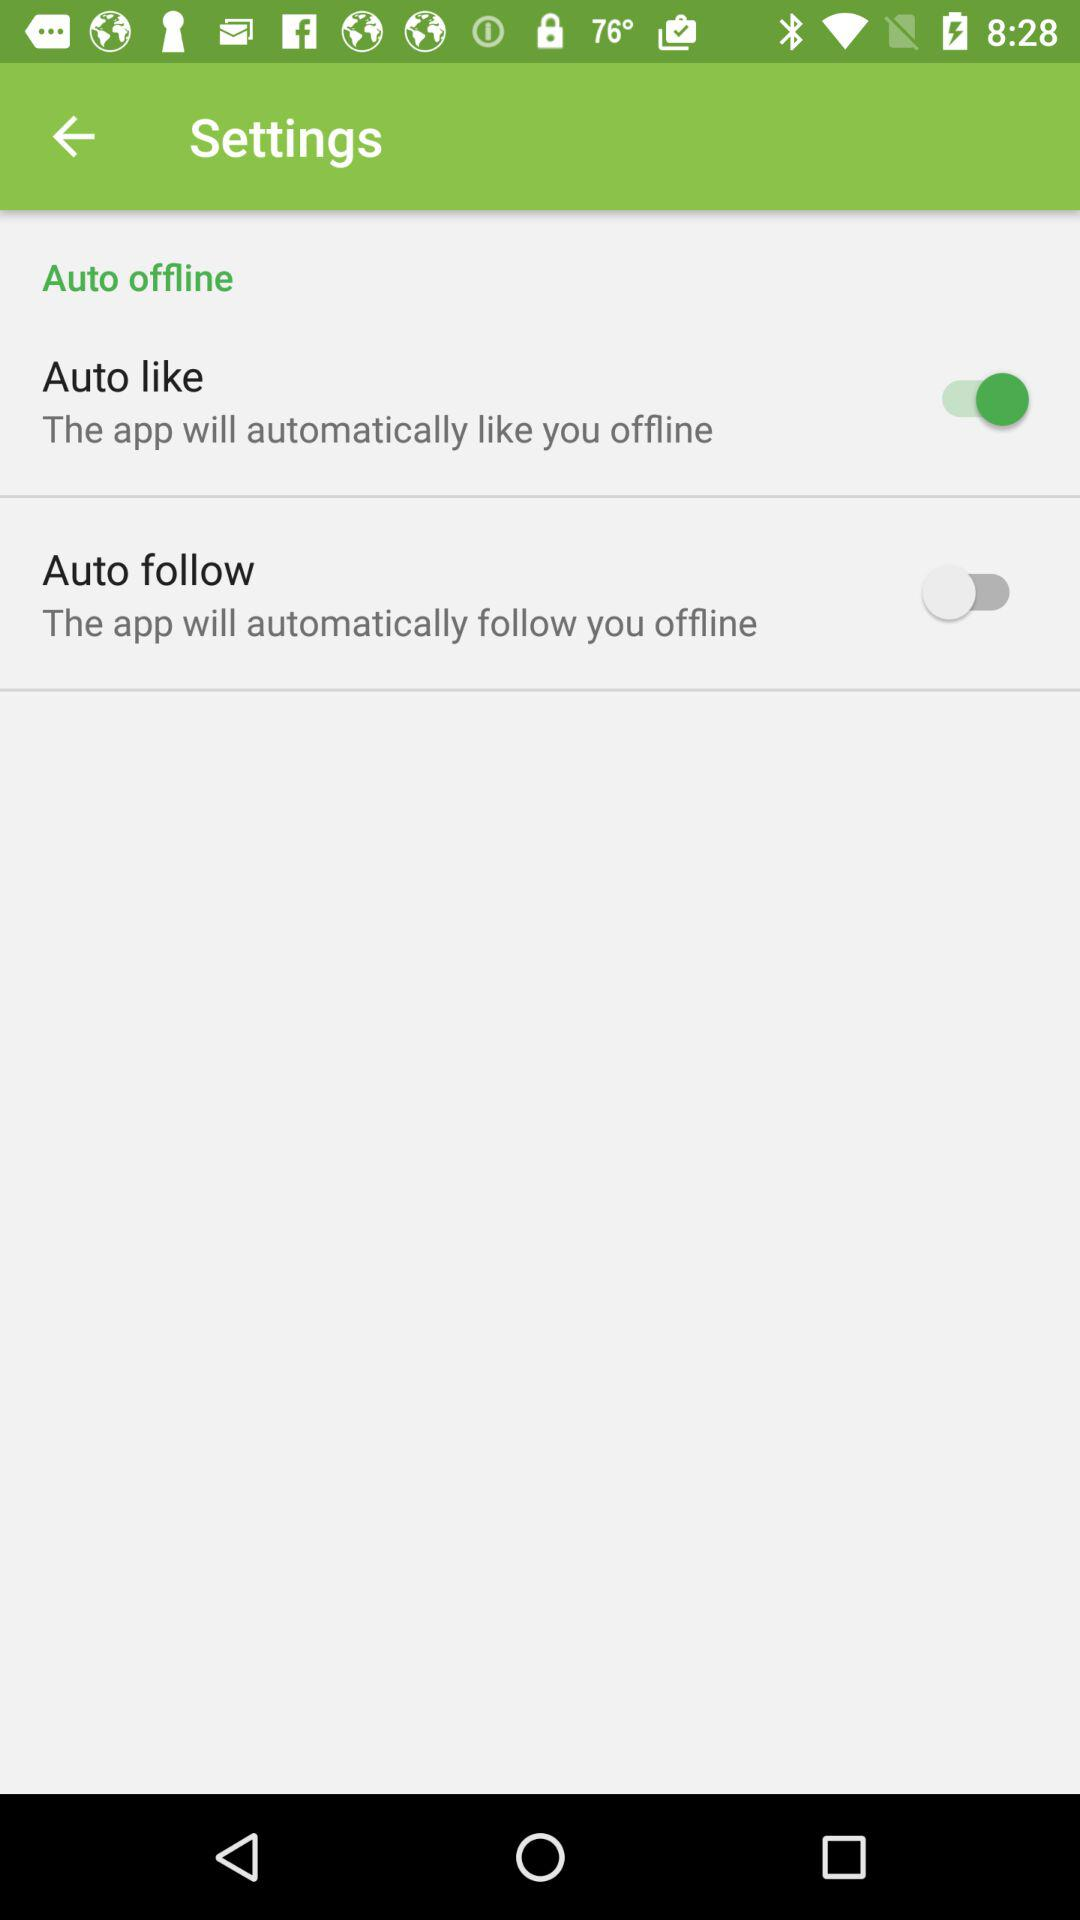What is the current status of "Auto follow"? The status is "off". 